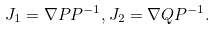Convert formula to latex. <formula><loc_0><loc_0><loc_500><loc_500>J _ { 1 } = \nabla P P ^ { - 1 } , J _ { 2 } = \nabla Q P ^ { - 1 } .</formula> 